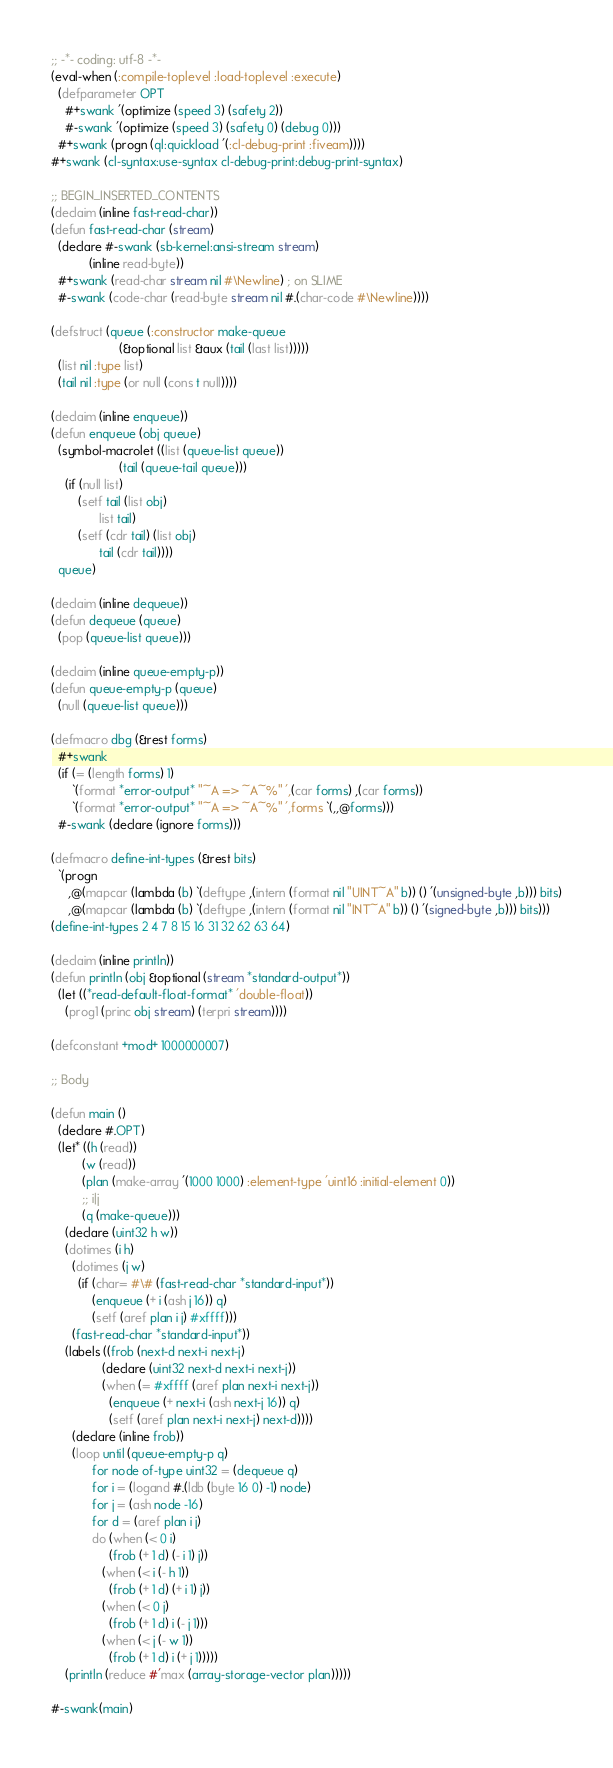Convert code to text. <code><loc_0><loc_0><loc_500><loc_500><_Lisp_>;; -*- coding: utf-8 -*-
(eval-when (:compile-toplevel :load-toplevel :execute)
  (defparameter OPT
    #+swank '(optimize (speed 3) (safety 2))
    #-swank '(optimize (speed 3) (safety 0) (debug 0)))
  #+swank (progn (ql:quickload '(:cl-debug-print :fiveam))))
#+swank (cl-syntax:use-syntax cl-debug-print:debug-print-syntax)

;; BEGIN_INSERTED_CONTENTS
(declaim (inline fast-read-char))
(defun fast-read-char (stream)
  (declare #-swank (sb-kernel:ansi-stream stream)
           (inline read-byte))
  #+swank (read-char stream nil #\Newline) ; on SLIME
  #-swank (code-char (read-byte stream nil #.(char-code #\Newline))))

(defstruct (queue (:constructor make-queue
                    (&optional list &aux (tail (last list)))))
  (list nil :type list)
  (tail nil :type (or null (cons t null))))

(declaim (inline enqueue))
(defun enqueue (obj queue)
  (symbol-macrolet ((list (queue-list queue))
                    (tail (queue-tail queue)))
    (if (null list)
        (setf tail (list obj)
              list tail)
        (setf (cdr tail) (list obj)
              tail (cdr tail))))
  queue)

(declaim (inline dequeue))
(defun dequeue (queue)
  (pop (queue-list queue)))

(declaim (inline queue-empty-p))
(defun queue-empty-p (queue)
  (null (queue-list queue)))

(defmacro dbg (&rest forms)
  #+swank
  (if (= (length forms) 1)
      `(format *error-output* "~A => ~A~%" ',(car forms) ,(car forms))
      `(format *error-output* "~A => ~A~%" ',forms `(,,@forms)))
  #-swank (declare (ignore forms)))

(defmacro define-int-types (&rest bits)
  `(progn
     ,@(mapcar (lambda (b) `(deftype ,(intern (format nil "UINT~A" b)) () '(unsigned-byte ,b))) bits)
     ,@(mapcar (lambda (b) `(deftype ,(intern (format nil "INT~A" b)) () '(signed-byte ,b))) bits)))
(define-int-types 2 4 7 8 15 16 31 32 62 63 64)

(declaim (inline println))
(defun println (obj &optional (stream *standard-output*))
  (let ((*read-default-float-format* 'double-float))
    (prog1 (princ obj stream) (terpri stream))))

(defconstant +mod+ 1000000007)

;; Body

(defun main ()
  (declare #.OPT)
  (let* ((h (read))
         (w (read))
         (plan (make-array '(1000 1000) :element-type 'uint16 :initial-element 0))
         ;; i|j
         (q (make-queue)))
    (declare (uint32 h w))
    (dotimes (i h)
      (dotimes (j w)
        (if (char= #\# (fast-read-char *standard-input*))
            (enqueue (+ i (ash j 16)) q)
            (setf (aref plan i j) #xffff)))
      (fast-read-char *standard-input*))
    (labels ((frob (next-d next-i next-j)
               (declare (uint32 next-d next-i next-j))
               (when (= #xffff (aref plan next-i next-j))
                 (enqueue (+ next-i (ash next-j 16)) q)
                 (setf (aref plan next-i next-j) next-d))))
      (declare (inline frob))
      (loop until (queue-empty-p q)
            for node of-type uint32 = (dequeue q)
            for i = (logand #.(ldb (byte 16 0) -1) node)
            for j = (ash node -16)
            for d = (aref plan i j)
            do (when (< 0 i)
                 (frob (+ 1 d) (- i 1) j))
               (when (< i (- h 1))
                 (frob (+ 1 d) (+ i 1) j))
               (when (< 0 j)
                 (frob (+ 1 d) i (- j 1)))
               (when (< j (- w 1))
                 (frob (+ 1 d) i (+ j 1)))))
    (println (reduce #'max (array-storage-vector plan)))))

#-swank(main)
</code> 